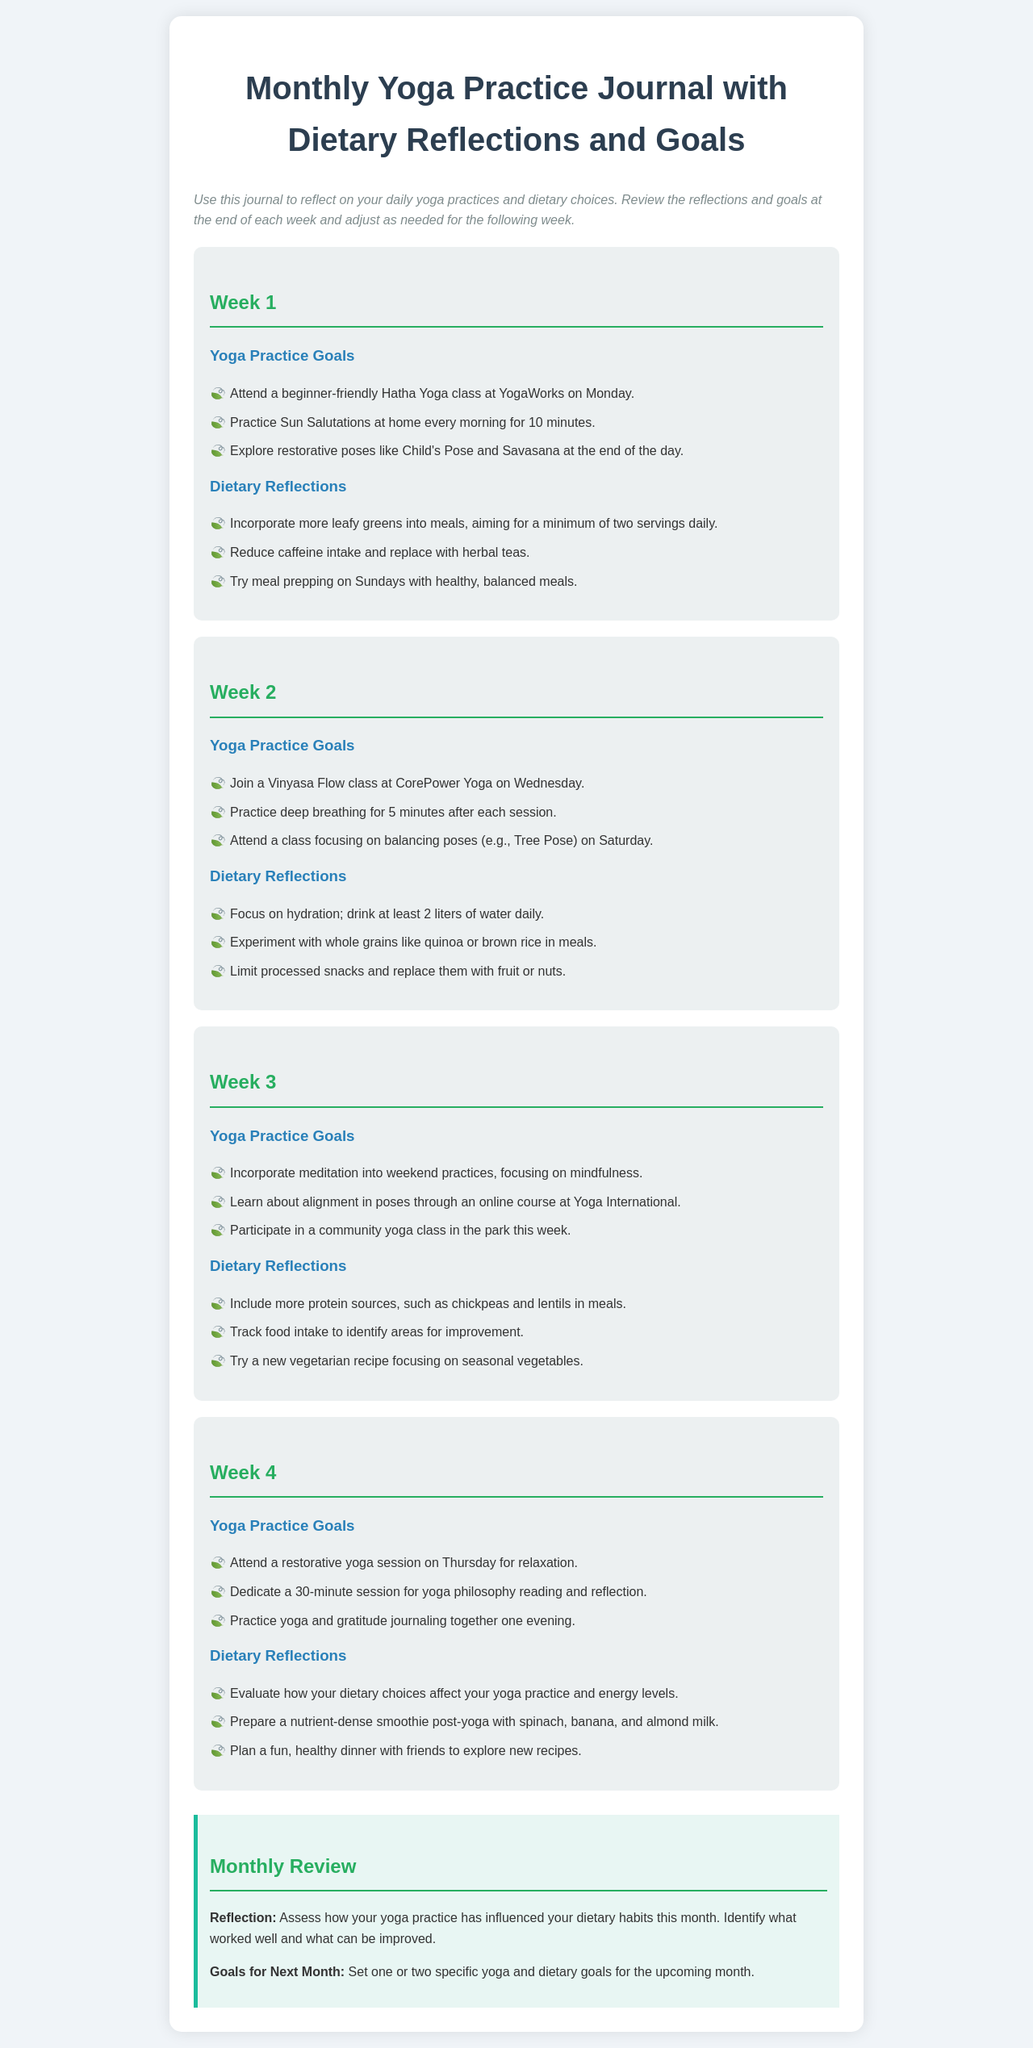What is the title of the document? The title is found in the main heading at the top of the document.
Answer: Monthly Yoga Practice Journal with Dietary Reflections and Goals How many weeks are included in the journal? The document contains sections labeled for each of the four weeks.
Answer: 4 What is one goal for Week 1? This information can be found in the "Yoga Practice Goals" section under Week 1.
Answer: Attend a beginner-friendly Hatha Yoga class at YogaWorks on Monday What type of yoga class is scheduled for Week 2? The document specifies that a Vinyasa Flow class is planned for Week 2.
Answer: Vinyasa Flow What dietary reflection is suggested for Week 3? The dietary reflections are listed under each week, specifically under Week 3’s heading.
Answer: Include more protein sources, such as chickpeas and lentils in meals What is the main focus of the Monthly Review section? This section summarizes the overall reflections from the month and sets goals for the next.
Answer: Assess how your yoga practice has influenced your dietary habits this month How many liters of water should be consumed daily according to Week 2? The reflection section specifies a hydration goal for Week 2.
Answer: 2 liters What is the purpose of the instructions at the beginning of the document? The instructions provide guidance on how to use the journal for reflections and goals.
Answer: To reflect on daily yoga practices and dietary choices 